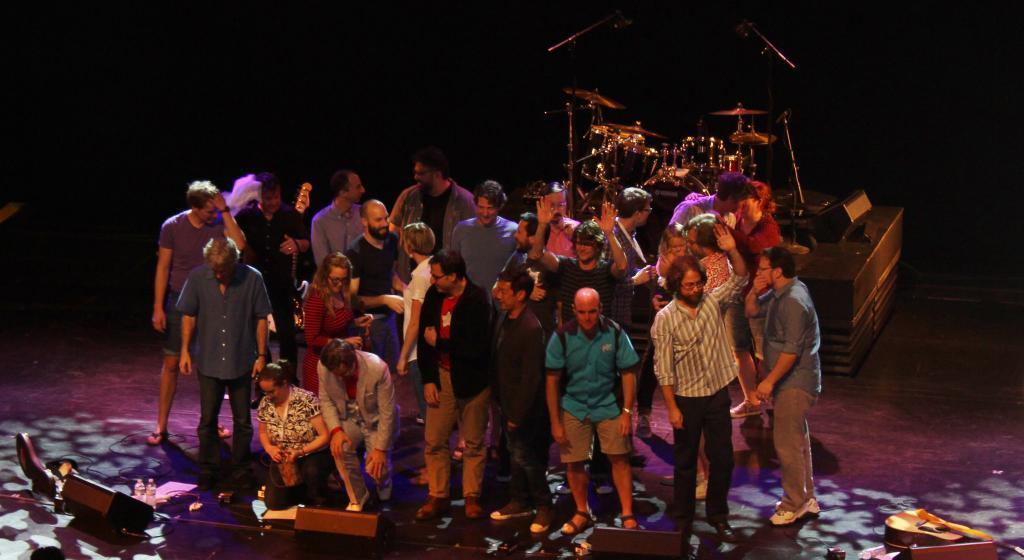Please provide a concise description of this image. In this image I can see a group of people. In the background, I can see the instruments. 